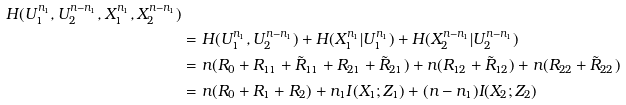Convert formula to latex. <formula><loc_0><loc_0><loc_500><loc_500>{ H ( U _ { 1 } ^ { n _ { 1 } } , U _ { 2 } ^ { n - n _ { 1 } } , X _ { 1 } ^ { n _ { 1 } } , X _ { 2 } ^ { n - n _ { 1 } } ) } & \\ & = H ( U _ { 1 } ^ { n _ { 1 } } , U _ { 2 } ^ { n - n _ { 1 } } ) + H ( X _ { 1 } ^ { n _ { 1 } } | U _ { 1 } ^ { n _ { 1 } } ) + H ( X _ { 2 } ^ { n - n _ { 1 } } | U _ { 2 } ^ { n - n _ { 1 } } ) \\ & = n ( R _ { 0 } + R _ { 1 1 } + \tilde { R } _ { 1 1 } + R _ { 2 1 } + \tilde { R } _ { 2 1 } ) + n ( R _ { 1 2 } + \tilde { R } _ { 1 2 } ) + n ( R _ { 2 2 } + \tilde { R } _ { 2 2 } ) \\ & = n ( R _ { 0 } + R _ { 1 } + R _ { 2 } ) + n _ { 1 } I ( X _ { 1 } ; Z _ { 1 } ) + ( n - n _ { 1 } ) I ( X _ { 2 } ; Z _ { 2 } )</formula> 